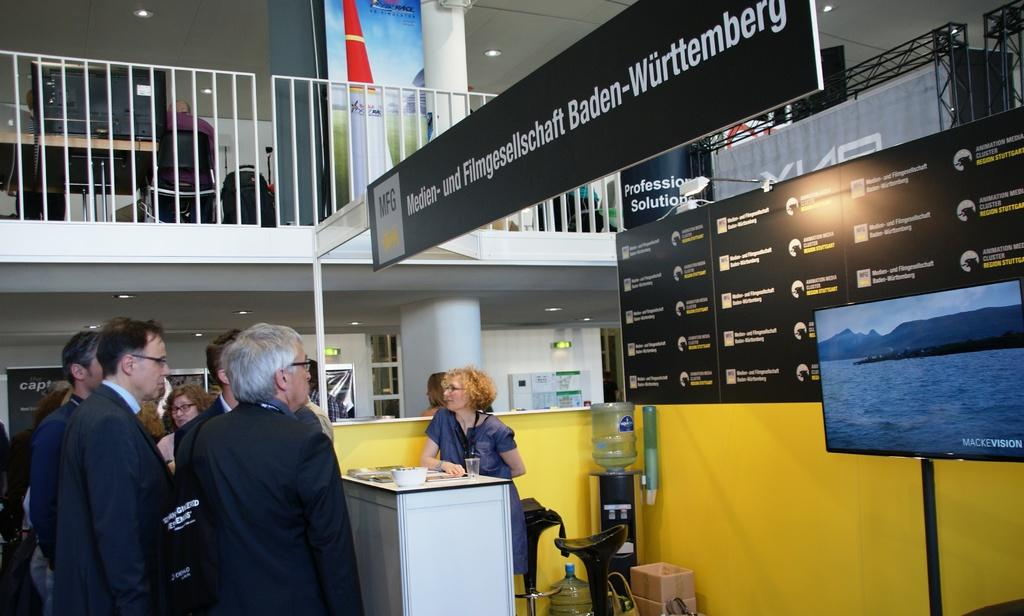<image>
Give a short and clear explanation of the subsequent image. Men are grouped in front of a woman at a desk underneath a sign for MFG. 